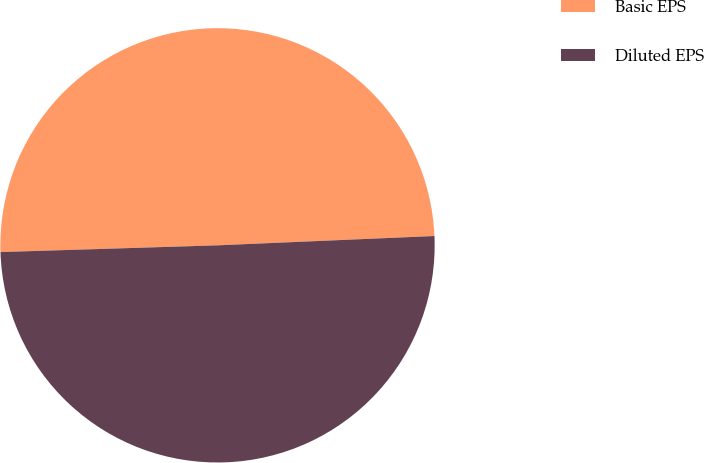Convert chart to OTSL. <chart><loc_0><loc_0><loc_500><loc_500><pie_chart><fcel>Basic EPS<fcel>Diluted EPS<nl><fcel>49.81%<fcel>50.19%<nl></chart> 